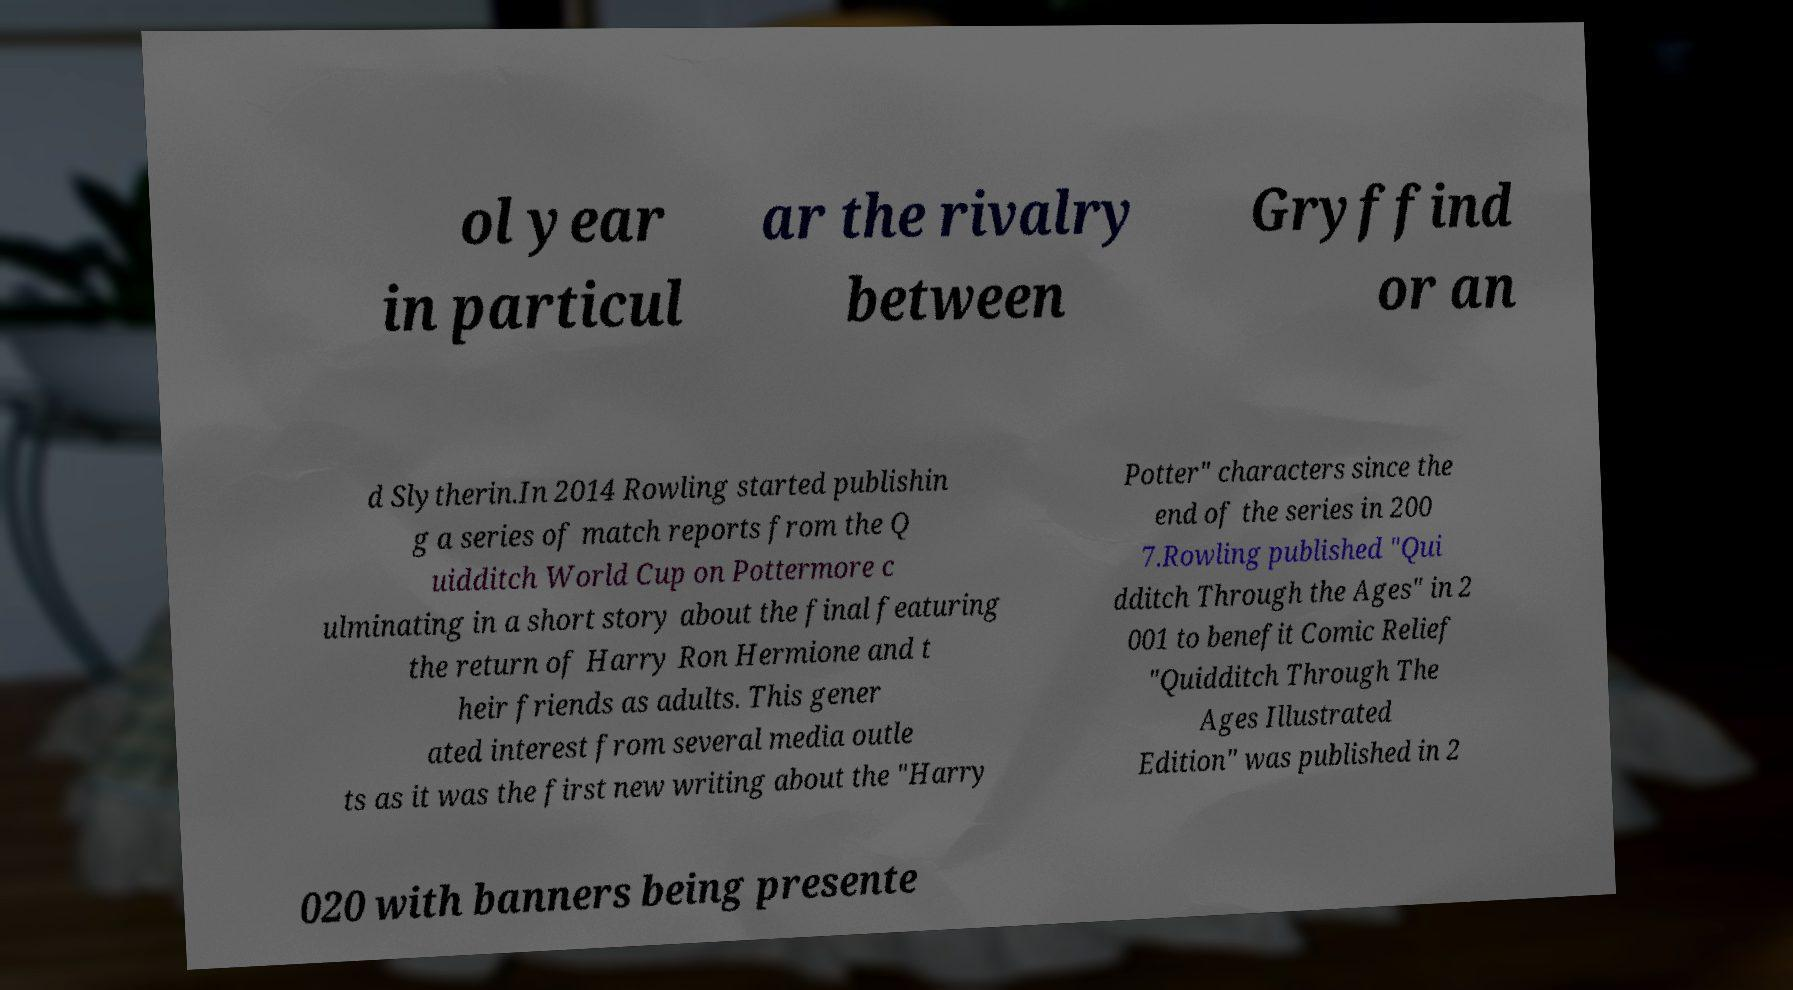Could you extract and type out the text from this image? ol year in particul ar the rivalry between Gryffind or an d Slytherin.In 2014 Rowling started publishin g a series of match reports from the Q uidditch World Cup on Pottermore c ulminating in a short story about the final featuring the return of Harry Ron Hermione and t heir friends as adults. This gener ated interest from several media outle ts as it was the first new writing about the "Harry Potter" characters since the end of the series in 200 7.Rowling published "Qui dditch Through the Ages" in 2 001 to benefit Comic Relief "Quidditch Through The Ages Illustrated Edition" was published in 2 020 with banners being presente 